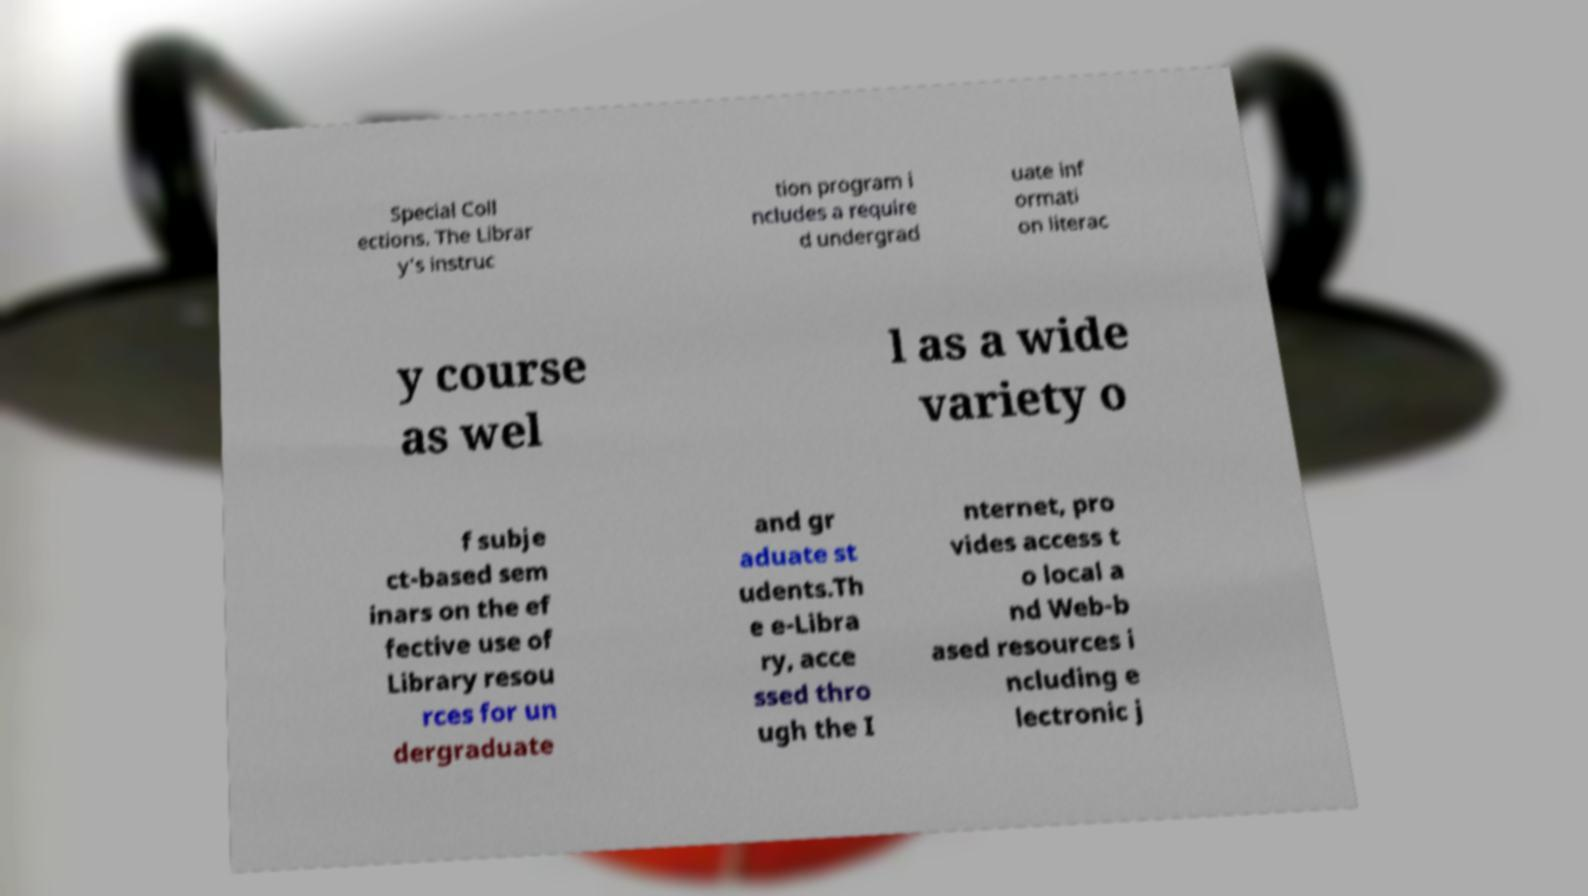Can you read and provide the text displayed in the image?This photo seems to have some interesting text. Can you extract and type it out for me? Special Coll ections. The Librar y's instruc tion program i ncludes a require d undergrad uate inf ormati on literac y course as wel l as a wide variety o f subje ct-based sem inars on the ef fective use of Library resou rces for un dergraduate and gr aduate st udents.Th e e-Libra ry, acce ssed thro ugh the I nternet, pro vides access t o local a nd Web-b ased resources i ncluding e lectronic j 